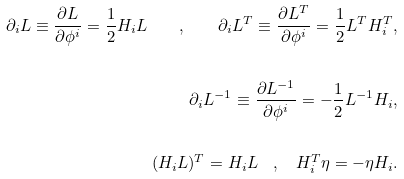<formula> <loc_0><loc_0><loc_500><loc_500>\partial _ { i } L \equiv \frac { \partial L } { \partial \phi ^ { i } } = \frac { 1 } { 2 } H _ { i } L \quad , \quad \partial _ { i } L ^ { T } \equiv \frac { \partial L ^ { T } } { \partial \phi ^ { i } } = \frac { 1 } { 2 } L ^ { T } H _ { i } ^ { T } , \\ \\ \partial _ { i } L ^ { - 1 } \equiv \frac { \partial L ^ { - 1 } } { \partial \phi ^ { i } } = - \frac { 1 } { 2 } L ^ { - 1 } H _ { i } , \\ \\ ( H _ { i } L ) ^ { T } = H _ { i } L \quad , \quad H _ { i } ^ { T } \eta = - \eta H _ { i } .</formula> 